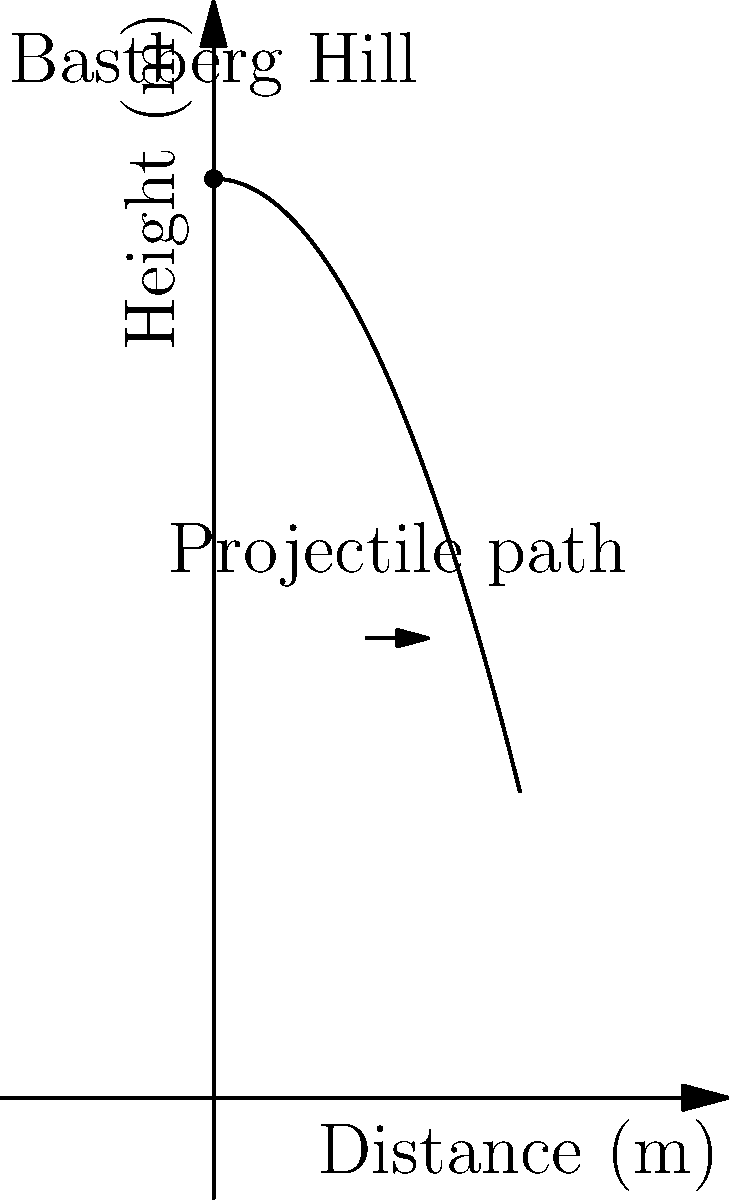From the top of Bastberg Hill, standing at 300 meters above the ground, you launch a catapult projectile. The trajectory of the projectile can be modeled by the function $h(x) = 300 - 0.02x^2$, where $h$ is the height in meters and $x$ is the horizontal distance in meters. How far does the projectile travel horizontally before hitting the ground? To solve this problem, we need to follow these steps:

1) The projectile hits the ground when its height $h(x)$ is equal to zero.
   So, we need to solve the equation: $h(x) = 0$

2) Substituting the given function:
   $300 - 0.02x^2 = 0$

3) Rearranging the equation:
   $0.02x^2 = 300$

4) Dividing both sides by 0.02:
   $x^2 = 15000$

5) Taking the square root of both sides:
   $x = \sqrt{15000}$

6) Simplifying:
   $x = 10\sqrt{150} \approx 122.47$ meters

7) We take the positive root because distance cannot be negative.

Therefore, the projectile travels approximately 122.47 meters horizontally before hitting the ground.
Answer: $10\sqrt{150}$ meters 